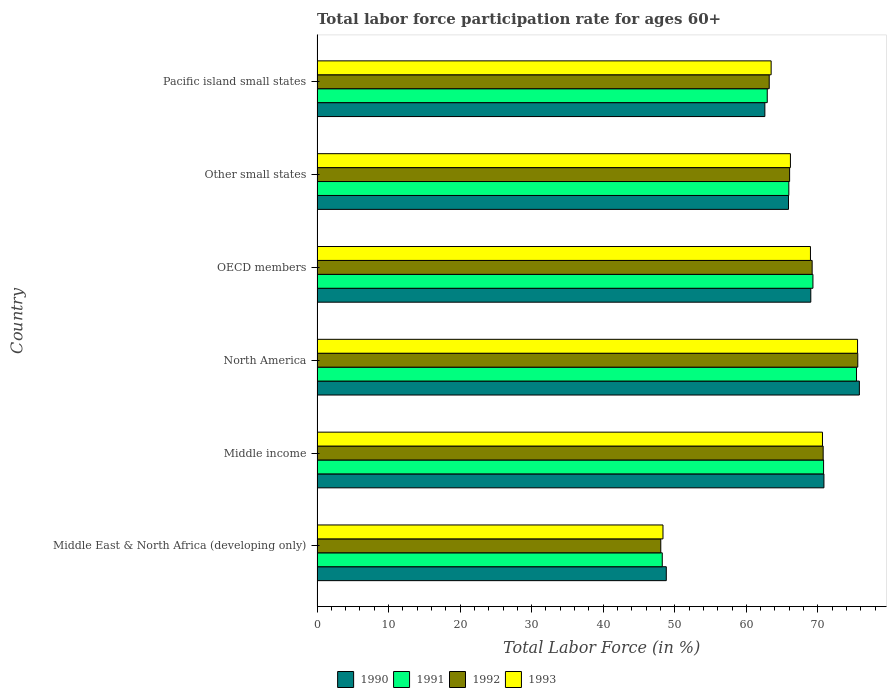How many groups of bars are there?
Give a very brief answer. 6. Are the number of bars per tick equal to the number of legend labels?
Your response must be concise. Yes. How many bars are there on the 5th tick from the top?
Ensure brevity in your answer.  4. How many bars are there on the 3rd tick from the bottom?
Keep it short and to the point. 4. In how many cases, is the number of bars for a given country not equal to the number of legend labels?
Provide a short and direct response. 0. What is the labor force participation rate in 1991 in Other small states?
Your answer should be compact. 65.94. Across all countries, what is the maximum labor force participation rate in 1992?
Offer a very short reply. 75.58. Across all countries, what is the minimum labor force participation rate in 1992?
Your response must be concise. 48.04. In which country was the labor force participation rate in 1990 maximum?
Your response must be concise. North America. In which country was the labor force participation rate in 1990 minimum?
Provide a short and direct response. Middle East & North Africa (developing only). What is the total labor force participation rate in 1990 in the graph?
Provide a succinct answer. 392.97. What is the difference between the labor force participation rate in 1993 in Other small states and that in Pacific island small states?
Offer a terse response. 2.69. What is the difference between the labor force participation rate in 1991 in Other small states and the labor force participation rate in 1993 in Middle income?
Your answer should be compact. -4.7. What is the average labor force participation rate in 1993 per country?
Provide a short and direct response. 65.52. What is the difference between the labor force participation rate in 1990 and labor force participation rate in 1991 in North America?
Offer a terse response. 0.4. In how many countries, is the labor force participation rate in 1992 greater than 76 %?
Your answer should be compact. 0. What is the ratio of the labor force participation rate in 1993 in Other small states to that in Pacific island small states?
Keep it short and to the point. 1.04. What is the difference between the highest and the second highest labor force participation rate in 1991?
Offer a very short reply. 4.6. What is the difference between the highest and the lowest labor force participation rate in 1990?
Give a very brief answer. 26.99. In how many countries, is the labor force participation rate in 1990 greater than the average labor force participation rate in 1990 taken over all countries?
Keep it short and to the point. 4. Is it the case that in every country, the sum of the labor force participation rate in 1991 and labor force participation rate in 1990 is greater than the sum of labor force participation rate in 1993 and labor force participation rate in 1992?
Give a very brief answer. No. What does the 1st bar from the top in OECD members represents?
Your answer should be compact. 1993. How many bars are there?
Give a very brief answer. 24. What is the difference between two consecutive major ticks on the X-axis?
Your answer should be very brief. 10. Are the values on the major ticks of X-axis written in scientific E-notation?
Provide a succinct answer. No. Does the graph contain any zero values?
Your answer should be very brief. No. How many legend labels are there?
Provide a short and direct response. 4. How are the legend labels stacked?
Your answer should be compact. Horizontal. What is the title of the graph?
Offer a terse response. Total labor force participation rate for ages 60+. What is the label or title of the X-axis?
Your response must be concise. Total Labor Force (in %). What is the Total Labor Force (in %) in 1990 in Middle East & North Africa (developing only)?
Your response must be concise. 48.82. What is the Total Labor Force (in %) of 1991 in Middle East & North Africa (developing only)?
Keep it short and to the point. 48.25. What is the Total Labor Force (in %) in 1992 in Middle East & North Africa (developing only)?
Keep it short and to the point. 48.04. What is the Total Labor Force (in %) in 1993 in Middle East & North Africa (developing only)?
Offer a terse response. 48.35. What is the Total Labor Force (in %) in 1990 in Middle income?
Provide a succinct answer. 70.85. What is the Total Labor Force (in %) in 1991 in Middle income?
Offer a very short reply. 70.8. What is the Total Labor Force (in %) of 1992 in Middle income?
Your answer should be very brief. 70.74. What is the Total Labor Force (in %) of 1993 in Middle income?
Ensure brevity in your answer.  70.64. What is the Total Labor Force (in %) of 1990 in North America?
Ensure brevity in your answer.  75.8. What is the Total Labor Force (in %) of 1991 in North America?
Provide a short and direct response. 75.4. What is the Total Labor Force (in %) in 1992 in North America?
Give a very brief answer. 75.58. What is the Total Labor Force (in %) of 1993 in North America?
Provide a succinct answer. 75.55. What is the Total Labor Force (in %) of 1990 in OECD members?
Keep it short and to the point. 69.01. What is the Total Labor Force (in %) of 1991 in OECD members?
Provide a short and direct response. 69.31. What is the Total Labor Force (in %) of 1992 in OECD members?
Keep it short and to the point. 69.2. What is the Total Labor Force (in %) in 1993 in OECD members?
Provide a succinct answer. 68.97. What is the Total Labor Force (in %) in 1990 in Other small states?
Ensure brevity in your answer.  65.9. What is the Total Labor Force (in %) in 1991 in Other small states?
Provide a succinct answer. 65.94. What is the Total Labor Force (in %) in 1992 in Other small states?
Provide a short and direct response. 66.05. What is the Total Labor Force (in %) in 1993 in Other small states?
Make the answer very short. 66.16. What is the Total Labor Force (in %) of 1990 in Pacific island small states?
Keep it short and to the point. 62.59. What is the Total Labor Force (in %) of 1991 in Pacific island small states?
Your answer should be very brief. 62.93. What is the Total Labor Force (in %) of 1992 in Pacific island small states?
Your answer should be compact. 63.2. What is the Total Labor Force (in %) of 1993 in Pacific island small states?
Make the answer very short. 63.47. Across all countries, what is the maximum Total Labor Force (in %) of 1990?
Offer a terse response. 75.8. Across all countries, what is the maximum Total Labor Force (in %) of 1991?
Offer a very short reply. 75.4. Across all countries, what is the maximum Total Labor Force (in %) in 1992?
Your response must be concise. 75.58. Across all countries, what is the maximum Total Labor Force (in %) in 1993?
Your response must be concise. 75.55. Across all countries, what is the minimum Total Labor Force (in %) of 1990?
Offer a very short reply. 48.82. Across all countries, what is the minimum Total Labor Force (in %) in 1991?
Give a very brief answer. 48.25. Across all countries, what is the minimum Total Labor Force (in %) in 1992?
Keep it short and to the point. 48.04. Across all countries, what is the minimum Total Labor Force (in %) in 1993?
Your answer should be compact. 48.35. What is the total Total Labor Force (in %) in 1990 in the graph?
Your answer should be very brief. 392.97. What is the total Total Labor Force (in %) of 1991 in the graph?
Provide a short and direct response. 392.64. What is the total Total Labor Force (in %) of 1992 in the graph?
Keep it short and to the point. 392.82. What is the total Total Labor Force (in %) in 1993 in the graph?
Provide a short and direct response. 393.15. What is the difference between the Total Labor Force (in %) in 1990 in Middle East & North Africa (developing only) and that in Middle income?
Ensure brevity in your answer.  -22.03. What is the difference between the Total Labor Force (in %) in 1991 in Middle East & North Africa (developing only) and that in Middle income?
Your response must be concise. -22.55. What is the difference between the Total Labor Force (in %) in 1992 in Middle East & North Africa (developing only) and that in Middle income?
Your answer should be very brief. -22.7. What is the difference between the Total Labor Force (in %) of 1993 in Middle East & North Africa (developing only) and that in Middle income?
Offer a very short reply. -22.29. What is the difference between the Total Labor Force (in %) of 1990 in Middle East & North Africa (developing only) and that in North America?
Your response must be concise. -26.99. What is the difference between the Total Labor Force (in %) in 1991 in Middle East & North Africa (developing only) and that in North America?
Provide a succinct answer. -27.15. What is the difference between the Total Labor Force (in %) of 1992 in Middle East & North Africa (developing only) and that in North America?
Offer a terse response. -27.53. What is the difference between the Total Labor Force (in %) of 1993 in Middle East & North Africa (developing only) and that in North America?
Make the answer very short. -27.2. What is the difference between the Total Labor Force (in %) in 1990 in Middle East & North Africa (developing only) and that in OECD members?
Keep it short and to the point. -20.2. What is the difference between the Total Labor Force (in %) of 1991 in Middle East & North Africa (developing only) and that in OECD members?
Your answer should be very brief. -21.06. What is the difference between the Total Labor Force (in %) of 1992 in Middle East & North Africa (developing only) and that in OECD members?
Your answer should be very brief. -21.16. What is the difference between the Total Labor Force (in %) of 1993 in Middle East & North Africa (developing only) and that in OECD members?
Ensure brevity in your answer.  -20.61. What is the difference between the Total Labor Force (in %) in 1990 in Middle East & North Africa (developing only) and that in Other small states?
Your answer should be very brief. -17.08. What is the difference between the Total Labor Force (in %) in 1991 in Middle East & North Africa (developing only) and that in Other small states?
Offer a very short reply. -17.69. What is the difference between the Total Labor Force (in %) in 1992 in Middle East & North Africa (developing only) and that in Other small states?
Keep it short and to the point. -18.01. What is the difference between the Total Labor Force (in %) in 1993 in Middle East & North Africa (developing only) and that in Other small states?
Offer a terse response. -17.81. What is the difference between the Total Labor Force (in %) in 1990 in Middle East & North Africa (developing only) and that in Pacific island small states?
Your answer should be compact. -13.78. What is the difference between the Total Labor Force (in %) of 1991 in Middle East & North Africa (developing only) and that in Pacific island small states?
Offer a terse response. -14.67. What is the difference between the Total Labor Force (in %) in 1992 in Middle East & North Africa (developing only) and that in Pacific island small states?
Provide a succinct answer. -15.16. What is the difference between the Total Labor Force (in %) of 1993 in Middle East & North Africa (developing only) and that in Pacific island small states?
Make the answer very short. -15.12. What is the difference between the Total Labor Force (in %) of 1990 in Middle income and that in North America?
Your answer should be very brief. -4.95. What is the difference between the Total Labor Force (in %) of 1991 in Middle income and that in North America?
Give a very brief answer. -4.6. What is the difference between the Total Labor Force (in %) of 1992 in Middle income and that in North America?
Offer a very short reply. -4.84. What is the difference between the Total Labor Force (in %) in 1993 in Middle income and that in North America?
Offer a very short reply. -4.9. What is the difference between the Total Labor Force (in %) in 1990 in Middle income and that in OECD members?
Your response must be concise. 1.84. What is the difference between the Total Labor Force (in %) in 1991 in Middle income and that in OECD members?
Your answer should be very brief. 1.49. What is the difference between the Total Labor Force (in %) of 1992 in Middle income and that in OECD members?
Make the answer very short. 1.54. What is the difference between the Total Labor Force (in %) of 1993 in Middle income and that in OECD members?
Provide a short and direct response. 1.68. What is the difference between the Total Labor Force (in %) in 1990 in Middle income and that in Other small states?
Your response must be concise. 4.95. What is the difference between the Total Labor Force (in %) in 1991 in Middle income and that in Other small states?
Your answer should be very brief. 4.86. What is the difference between the Total Labor Force (in %) of 1992 in Middle income and that in Other small states?
Offer a terse response. 4.69. What is the difference between the Total Labor Force (in %) of 1993 in Middle income and that in Other small states?
Provide a succinct answer. 4.48. What is the difference between the Total Labor Force (in %) in 1990 in Middle income and that in Pacific island small states?
Keep it short and to the point. 8.26. What is the difference between the Total Labor Force (in %) of 1991 in Middle income and that in Pacific island small states?
Give a very brief answer. 7.87. What is the difference between the Total Labor Force (in %) in 1992 in Middle income and that in Pacific island small states?
Give a very brief answer. 7.54. What is the difference between the Total Labor Force (in %) of 1993 in Middle income and that in Pacific island small states?
Offer a very short reply. 7.17. What is the difference between the Total Labor Force (in %) of 1990 in North America and that in OECD members?
Keep it short and to the point. 6.79. What is the difference between the Total Labor Force (in %) in 1991 in North America and that in OECD members?
Provide a succinct answer. 6.09. What is the difference between the Total Labor Force (in %) in 1992 in North America and that in OECD members?
Offer a terse response. 6.38. What is the difference between the Total Labor Force (in %) of 1993 in North America and that in OECD members?
Ensure brevity in your answer.  6.58. What is the difference between the Total Labor Force (in %) in 1990 in North America and that in Other small states?
Give a very brief answer. 9.91. What is the difference between the Total Labor Force (in %) in 1991 in North America and that in Other small states?
Your answer should be very brief. 9.46. What is the difference between the Total Labor Force (in %) of 1992 in North America and that in Other small states?
Keep it short and to the point. 9.53. What is the difference between the Total Labor Force (in %) of 1993 in North America and that in Other small states?
Offer a terse response. 9.38. What is the difference between the Total Labor Force (in %) of 1990 in North America and that in Pacific island small states?
Provide a succinct answer. 13.21. What is the difference between the Total Labor Force (in %) of 1991 in North America and that in Pacific island small states?
Make the answer very short. 12.48. What is the difference between the Total Labor Force (in %) in 1992 in North America and that in Pacific island small states?
Your answer should be compact. 12.38. What is the difference between the Total Labor Force (in %) of 1993 in North America and that in Pacific island small states?
Provide a succinct answer. 12.08. What is the difference between the Total Labor Force (in %) of 1990 in OECD members and that in Other small states?
Make the answer very short. 3.12. What is the difference between the Total Labor Force (in %) in 1991 in OECD members and that in Other small states?
Your answer should be compact. 3.37. What is the difference between the Total Labor Force (in %) of 1992 in OECD members and that in Other small states?
Provide a short and direct response. 3.15. What is the difference between the Total Labor Force (in %) of 1993 in OECD members and that in Other small states?
Offer a terse response. 2.8. What is the difference between the Total Labor Force (in %) of 1990 in OECD members and that in Pacific island small states?
Ensure brevity in your answer.  6.42. What is the difference between the Total Labor Force (in %) of 1991 in OECD members and that in Pacific island small states?
Ensure brevity in your answer.  6.39. What is the difference between the Total Labor Force (in %) of 1992 in OECD members and that in Pacific island small states?
Offer a very short reply. 6. What is the difference between the Total Labor Force (in %) in 1993 in OECD members and that in Pacific island small states?
Your response must be concise. 5.49. What is the difference between the Total Labor Force (in %) in 1990 in Other small states and that in Pacific island small states?
Ensure brevity in your answer.  3.3. What is the difference between the Total Labor Force (in %) in 1991 in Other small states and that in Pacific island small states?
Make the answer very short. 3.02. What is the difference between the Total Labor Force (in %) in 1992 in Other small states and that in Pacific island small states?
Make the answer very short. 2.85. What is the difference between the Total Labor Force (in %) in 1993 in Other small states and that in Pacific island small states?
Your response must be concise. 2.69. What is the difference between the Total Labor Force (in %) of 1990 in Middle East & North Africa (developing only) and the Total Labor Force (in %) of 1991 in Middle income?
Provide a succinct answer. -21.98. What is the difference between the Total Labor Force (in %) of 1990 in Middle East & North Africa (developing only) and the Total Labor Force (in %) of 1992 in Middle income?
Provide a succinct answer. -21.93. What is the difference between the Total Labor Force (in %) in 1990 in Middle East & North Africa (developing only) and the Total Labor Force (in %) in 1993 in Middle income?
Provide a succinct answer. -21.83. What is the difference between the Total Labor Force (in %) of 1991 in Middle East & North Africa (developing only) and the Total Labor Force (in %) of 1992 in Middle income?
Your answer should be compact. -22.49. What is the difference between the Total Labor Force (in %) of 1991 in Middle East & North Africa (developing only) and the Total Labor Force (in %) of 1993 in Middle income?
Provide a short and direct response. -22.39. What is the difference between the Total Labor Force (in %) in 1992 in Middle East & North Africa (developing only) and the Total Labor Force (in %) in 1993 in Middle income?
Offer a terse response. -22.6. What is the difference between the Total Labor Force (in %) in 1990 in Middle East & North Africa (developing only) and the Total Labor Force (in %) in 1991 in North America?
Ensure brevity in your answer.  -26.59. What is the difference between the Total Labor Force (in %) in 1990 in Middle East & North Africa (developing only) and the Total Labor Force (in %) in 1992 in North America?
Ensure brevity in your answer.  -26.76. What is the difference between the Total Labor Force (in %) of 1990 in Middle East & North Africa (developing only) and the Total Labor Force (in %) of 1993 in North America?
Provide a short and direct response. -26.73. What is the difference between the Total Labor Force (in %) in 1991 in Middle East & North Africa (developing only) and the Total Labor Force (in %) in 1992 in North America?
Provide a succinct answer. -27.33. What is the difference between the Total Labor Force (in %) of 1991 in Middle East & North Africa (developing only) and the Total Labor Force (in %) of 1993 in North America?
Your response must be concise. -27.3. What is the difference between the Total Labor Force (in %) in 1992 in Middle East & North Africa (developing only) and the Total Labor Force (in %) in 1993 in North America?
Offer a terse response. -27.5. What is the difference between the Total Labor Force (in %) of 1990 in Middle East & North Africa (developing only) and the Total Labor Force (in %) of 1991 in OECD members?
Offer a very short reply. -20.5. What is the difference between the Total Labor Force (in %) in 1990 in Middle East & North Africa (developing only) and the Total Labor Force (in %) in 1992 in OECD members?
Your answer should be very brief. -20.39. What is the difference between the Total Labor Force (in %) in 1990 in Middle East & North Africa (developing only) and the Total Labor Force (in %) in 1993 in OECD members?
Your answer should be compact. -20.15. What is the difference between the Total Labor Force (in %) of 1991 in Middle East & North Africa (developing only) and the Total Labor Force (in %) of 1992 in OECD members?
Your answer should be compact. -20.95. What is the difference between the Total Labor Force (in %) in 1991 in Middle East & North Africa (developing only) and the Total Labor Force (in %) in 1993 in OECD members?
Provide a short and direct response. -20.71. What is the difference between the Total Labor Force (in %) in 1992 in Middle East & North Africa (developing only) and the Total Labor Force (in %) in 1993 in OECD members?
Provide a short and direct response. -20.92. What is the difference between the Total Labor Force (in %) in 1990 in Middle East & North Africa (developing only) and the Total Labor Force (in %) in 1991 in Other small states?
Your answer should be very brief. -17.13. What is the difference between the Total Labor Force (in %) in 1990 in Middle East & North Africa (developing only) and the Total Labor Force (in %) in 1992 in Other small states?
Your answer should be very brief. -17.24. What is the difference between the Total Labor Force (in %) in 1990 in Middle East & North Africa (developing only) and the Total Labor Force (in %) in 1993 in Other small states?
Offer a very short reply. -17.35. What is the difference between the Total Labor Force (in %) of 1991 in Middle East & North Africa (developing only) and the Total Labor Force (in %) of 1992 in Other small states?
Provide a succinct answer. -17.8. What is the difference between the Total Labor Force (in %) of 1991 in Middle East & North Africa (developing only) and the Total Labor Force (in %) of 1993 in Other small states?
Provide a succinct answer. -17.91. What is the difference between the Total Labor Force (in %) in 1992 in Middle East & North Africa (developing only) and the Total Labor Force (in %) in 1993 in Other small states?
Your response must be concise. -18.12. What is the difference between the Total Labor Force (in %) in 1990 in Middle East & North Africa (developing only) and the Total Labor Force (in %) in 1991 in Pacific island small states?
Offer a very short reply. -14.11. What is the difference between the Total Labor Force (in %) of 1990 in Middle East & North Africa (developing only) and the Total Labor Force (in %) of 1992 in Pacific island small states?
Offer a terse response. -14.38. What is the difference between the Total Labor Force (in %) of 1990 in Middle East & North Africa (developing only) and the Total Labor Force (in %) of 1993 in Pacific island small states?
Provide a short and direct response. -14.65. What is the difference between the Total Labor Force (in %) in 1991 in Middle East & North Africa (developing only) and the Total Labor Force (in %) in 1992 in Pacific island small states?
Offer a very short reply. -14.95. What is the difference between the Total Labor Force (in %) of 1991 in Middle East & North Africa (developing only) and the Total Labor Force (in %) of 1993 in Pacific island small states?
Offer a terse response. -15.22. What is the difference between the Total Labor Force (in %) of 1992 in Middle East & North Africa (developing only) and the Total Labor Force (in %) of 1993 in Pacific island small states?
Make the answer very short. -15.43. What is the difference between the Total Labor Force (in %) in 1990 in Middle income and the Total Labor Force (in %) in 1991 in North America?
Offer a terse response. -4.55. What is the difference between the Total Labor Force (in %) of 1990 in Middle income and the Total Labor Force (in %) of 1992 in North America?
Offer a very short reply. -4.73. What is the difference between the Total Labor Force (in %) in 1990 in Middle income and the Total Labor Force (in %) in 1993 in North America?
Make the answer very short. -4.7. What is the difference between the Total Labor Force (in %) of 1991 in Middle income and the Total Labor Force (in %) of 1992 in North America?
Make the answer very short. -4.78. What is the difference between the Total Labor Force (in %) of 1991 in Middle income and the Total Labor Force (in %) of 1993 in North America?
Ensure brevity in your answer.  -4.75. What is the difference between the Total Labor Force (in %) of 1992 in Middle income and the Total Labor Force (in %) of 1993 in North America?
Your answer should be compact. -4.81. What is the difference between the Total Labor Force (in %) of 1990 in Middle income and the Total Labor Force (in %) of 1991 in OECD members?
Your answer should be very brief. 1.54. What is the difference between the Total Labor Force (in %) in 1990 in Middle income and the Total Labor Force (in %) in 1992 in OECD members?
Your response must be concise. 1.65. What is the difference between the Total Labor Force (in %) of 1990 in Middle income and the Total Labor Force (in %) of 1993 in OECD members?
Provide a succinct answer. 1.89. What is the difference between the Total Labor Force (in %) in 1991 in Middle income and the Total Labor Force (in %) in 1992 in OECD members?
Provide a succinct answer. 1.6. What is the difference between the Total Labor Force (in %) of 1991 in Middle income and the Total Labor Force (in %) of 1993 in OECD members?
Provide a short and direct response. 1.84. What is the difference between the Total Labor Force (in %) in 1992 in Middle income and the Total Labor Force (in %) in 1993 in OECD members?
Offer a terse response. 1.78. What is the difference between the Total Labor Force (in %) of 1990 in Middle income and the Total Labor Force (in %) of 1991 in Other small states?
Your answer should be very brief. 4.91. What is the difference between the Total Labor Force (in %) in 1990 in Middle income and the Total Labor Force (in %) in 1992 in Other small states?
Ensure brevity in your answer.  4.8. What is the difference between the Total Labor Force (in %) in 1990 in Middle income and the Total Labor Force (in %) in 1993 in Other small states?
Your answer should be very brief. 4.69. What is the difference between the Total Labor Force (in %) in 1991 in Middle income and the Total Labor Force (in %) in 1992 in Other small states?
Make the answer very short. 4.75. What is the difference between the Total Labor Force (in %) of 1991 in Middle income and the Total Labor Force (in %) of 1993 in Other small states?
Your answer should be very brief. 4.64. What is the difference between the Total Labor Force (in %) of 1992 in Middle income and the Total Labor Force (in %) of 1993 in Other small states?
Your answer should be very brief. 4.58. What is the difference between the Total Labor Force (in %) in 1990 in Middle income and the Total Labor Force (in %) in 1991 in Pacific island small states?
Give a very brief answer. 7.92. What is the difference between the Total Labor Force (in %) of 1990 in Middle income and the Total Labor Force (in %) of 1992 in Pacific island small states?
Provide a short and direct response. 7.65. What is the difference between the Total Labor Force (in %) of 1990 in Middle income and the Total Labor Force (in %) of 1993 in Pacific island small states?
Make the answer very short. 7.38. What is the difference between the Total Labor Force (in %) in 1991 in Middle income and the Total Labor Force (in %) in 1992 in Pacific island small states?
Offer a terse response. 7.6. What is the difference between the Total Labor Force (in %) of 1991 in Middle income and the Total Labor Force (in %) of 1993 in Pacific island small states?
Provide a succinct answer. 7.33. What is the difference between the Total Labor Force (in %) of 1992 in Middle income and the Total Labor Force (in %) of 1993 in Pacific island small states?
Ensure brevity in your answer.  7.27. What is the difference between the Total Labor Force (in %) of 1990 in North America and the Total Labor Force (in %) of 1991 in OECD members?
Ensure brevity in your answer.  6.49. What is the difference between the Total Labor Force (in %) in 1990 in North America and the Total Labor Force (in %) in 1992 in OECD members?
Provide a short and direct response. 6.6. What is the difference between the Total Labor Force (in %) of 1990 in North America and the Total Labor Force (in %) of 1993 in OECD members?
Make the answer very short. 6.84. What is the difference between the Total Labor Force (in %) of 1991 in North America and the Total Labor Force (in %) of 1992 in OECD members?
Provide a short and direct response. 6.2. What is the difference between the Total Labor Force (in %) in 1991 in North America and the Total Labor Force (in %) in 1993 in OECD members?
Give a very brief answer. 6.44. What is the difference between the Total Labor Force (in %) of 1992 in North America and the Total Labor Force (in %) of 1993 in OECD members?
Ensure brevity in your answer.  6.61. What is the difference between the Total Labor Force (in %) of 1990 in North America and the Total Labor Force (in %) of 1991 in Other small states?
Your answer should be compact. 9.86. What is the difference between the Total Labor Force (in %) of 1990 in North America and the Total Labor Force (in %) of 1992 in Other small states?
Your response must be concise. 9.75. What is the difference between the Total Labor Force (in %) in 1990 in North America and the Total Labor Force (in %) in 1993 in Other small states?
Your response must be concise. 9.64. What is the difference between the Total Labor Force (in %) of 1991 in North America and the Total Labor Force (in %) of 1992 in Other small states?
Your answer should be very brief. 9.35. What is the difference between the Total Labor Force (in %) of 1991 in North America and the Total Labor Force (in %) of 1993 in Other small states?
Ensure brevity in your answer.  9.24. What is the difference between the Total Labor Force (in %) in 1992 in North America and the Total Labor Force (in %) in 1993 in Other small states?
Offer a terse response. 9.41. What is the difference between the Total Labor Force (in %) of 1990 in North America and the Total Labor Force (in %) of 1991 in Pacific island small states?
Provide a short and direct response. 12.88. What is the difference between the Total Labor Force (in %) in 1990 in North America and the Total Labor Force (in %) in 1992 in Pacific island small states?
Provide a short and direct response. 12.6. What is the difference between the Total Labor Force (in %) in 1990 in North America and the Total Labor Force (in %) in 1993 in Pacific island small states?
Keep it short and to the point. 12.33. What is the difference between the Total Labor Force (in %) in 1991 in North America and the Total Labor Force (in %) in 1992 in Pacific island small states?
Provide a succinct answer. 12.2. What is the difference between the Total Labor Force (in %) of 1991 in North America and the Total Labor Force (in %) of 1993 in Pacific island small states?
Provide a short and direct response. 11.93. What is the difference between the Total Labor Force (in %) of 1992 in North America and the Total Labor Force (in %) of 1993 in Pacific island small states?
Make the answer very short. 12.11. What is the difference between the Total Labor Force (in %) of 1990 in OECD members and the Total Labor Force (in %) of 1991 in Other small states?
Make the answer very short. 3.07. What is the difference between the Total Labor Force (in %) of 1990 in OECD members and the Total Labor Force (in %) of 1992 in Other small states?
Offer a terse response. 2.96. What is the difference between the Total Labor Force (in %) of 1990 in OECD members and the Total Labor Force (in %) of 1993 in Other small states?
Give a very brief answer. 2.85. What is the difference between the Total Labor Force (in %) in 1991 in OECD members and the Total Labor Force (in %) in 1992 in Other small states?
Keep it short and to the point. 3.26. What is the difference between the Total Labor Force (in %) of 1991 in OECD members and the Total Labor Force (in %) of 1993 in Other small states?
Offer a very short reply. 3.15. What is the difference between the Total Labor Force (in %) of 1992 in OECD members and the Total Labor Force (in %) of 1993 in Other small states?
Your answer should be very brief. 3.04. What is the difference between the Total Labor Force (in %) of 1990 in OECD members and the Total Labor Force (in %) of 1991 in Pacific island small states?
Your response must be concise. 6.09. What is the difference between the Total Labor Force (in %) in 1990 in OECD members and the Total Labor Force (in %) in 1992 in Pacific island small states?
Provide a short and direct response. 5.81. What is the difference between the Total Labor Force (in %) in 1990 in OECD members and the Total Labor Force (in %) in 1993 in Pacific island small states?
Give a very brief answer. 5.54. What is the difference between the Total Labor Force (in %) of 1991 in OECD members and the Total Labor Force (in %) of 1992 in Pacific island small states?
Give a very brief answer. 6.11. What is the difference between the Total Labor Force (in %) in 1991 in OECD members and the Total Labor Force (in %) in 1993 in Pacific island small states?
Offer a very short reply. 5.84. What is the difference between the Total Labor Force (in %) of 1992 in OECD members and the Total Labor Force (in %) of 1993 in Pacific island small states?
Keep it short and to the point. 5.73. What is the difference between the Total Labor Force (in %) in 1990 in Other small states and the Total Labor Force (in %) in 1991 in Pacific island small states?
Give a very brief answer. 2.97. What is the difference between the Total Labor Force (in %) in 1990 in Other small states and the Total Labor Force (in %) in 1992 in Pacific island small states?
Make the answer very short. 2.7. What is the difference between the Total Labor Force (in %) of 1990 in Other small states and the Total Labor Force (in %) of 1993 in Pacific island small states?
Ensure brevity in your answer.  2.43. What is the difference between the Total Labor Force (in %) of 1991 in Other small states and the Total Labor Force (in %) of 1992 in Pacific island small states?
Keep it short and to the point. 2.74. What is the difference between the Total Labor Force (in %) in 1991 in Other small states and the Total Labor Force (in %) in 1993 in Pacific island small states?
Provide a short and direct response. 2.47. What is the difference between the Total Labor Force (in %) of 1992 in Other small states and the Total Labor Force (in %) of 1993 in Pacific island small states?
Ensure brevity in your answer.  2.58. What is the average Total Labor Force (in %) in 1990 per country?
Your response must be concise. 65.5. What is the average Total Labor Force (in %) of 1991 per country?
Your response must be concise. 65.44. What is the average Total Labor Force (in %) of 1992 per country?
Keep it short and to the point. 65.47. What is the average Total Labor Force (in %) in 1993 per country?
Your response must be concise. 65.52. What is the difference between the Total Labor Force (in %) in 1990 and Total Labor Force (in %) in 1991 in Middle East & North Africa (developing only)?
Your response must be concise. 0.56. What is the difference between the Total Labor Force (in %) of 1990 and Total Labor Force (in %) of 1992 in Middle East & North Africa (developing only)?
Keep it short and to the point. 0.77. What is the difference between the Total Labor Force (in %) in 1990 and Total Labor Force (in %) in 1993 in Middle East & North Africa (developing only)?
Give a very brief answer. 0.46. What is the difference between the Total Labor Force (in %) in 1991 and Total Labor Force (in %) in 1992 in Middle East & North Africa (developing only)?
Your response must be concise. 0.21. What is the difference between the Total Labor Force (in %) in 1991 and Total Labor Force (in %) in 1993 in Middle East & North Africa (developing only)?
Your answer should be compact. -0.1. What is the difference between the Total Labor Force (in %) of 1992 and Total Labor Force (in %) of 1993 in Middle East & North Africa (developing only)?
Offer a very short reply. -0.31. What is the difference between the Total Labor Force (in %) of 1990 and Total Labor Force (in %) of 1991 in Middle income?
Keep it short and to the point. 0.05. What is the difference between the Total Labor Force (in %) of 1990 and Total Labor Force (in %) of 1992 in Middle income?
Keep it short and to the point. 0.11. What is the difference between the Total Labor Force (in %) in 1990 and Total Labor Force (in %) in 1993 in Middle income?
Give a very brief answer. 0.21. What is the difference between the Total Labor Force (in %) of 1991 and Total Labor Force (in %) of 1992 in Middle income?
Give a very brief answer. 0.06. What is the difference between the Total Labor Force (in %) of 1991 and Total Labor Force (in %) of 1993 in Middle income?
Offer a terse response. 0.16. What is the difference between the Total Labor Force (in %) in 1992 and Total Labor Force (in %) in 1993 in Middle income?
Keep it short and to the point. 0.1. What is the difference between the Total Labor Force (in %) in 1990 and Total Labor Force (in %) in 1991 in North America?
Ensure brevity in your answer.  0.4. What is the difference between the Total Labor Force (in %) of 1990 and Total Labor Force (in %) of 1992 in North America?
Keep it short and to the point. 0.22. What is the difference between the Total Labor Force (in %) in 1990 and Total Labor Force (in %) in 1993 in North America?
Offer a terse response. 0.25. What is the difference between the Total Labor Force (in %) of 1991 and Total Labor Force (in %) of 1992 in North America?
Ensure brevity in your answer.  -0.18. What is the difference between the Total Labor Force (in %) in 1991 and Total Labor Force (in %) in 1993 in North America?
Your answer should be very brief. -0.15. What is the difference between the Total Labor Force (in %) in 1992 and Total Labor Force (in %) in 1993 in North America?
Offer a very short reply. 0.03. What is the difference between the Total Labor Force (in %) of 1990 and Total Labor Force (in %) of 1991 in OECD members?
Keep it short and to the point. -0.3. What is the difference between the Total Labor Force (in %) in 1990 and Total Labor Force (in %) in 1992 in OECD members?
Keep it short and to the point. -0.19. What is the difference between the Total Labor Force (in %) in 1990 and Total Labor Force (in %) in 1993 in OECD members?
Ensure brevity in your answer.  0.05. What is the difference between the Total Labor Force (in %) of 1991 and Total Labor Force (in %) of 1992 in OECD members?
Provide a succinct answer. 0.11. What is the difference between the Total Labor Force (in %) of 1991 and Total Labor Force (in %) of 1993 in OECD members?
Offer a very short reply. 0.35. What is the difference between the Total Labor Force (in %) of 1992 and Total Labor Force (in %) of 1993 in OECD members?
Make the answer very short. 0.24. What is the difference between the Total Labor Force (in %) in 1990 and Total Labor Force (in %) in 1991 in Other small states?
Your response must be concise. -0.05. What is the difference between the Total Labor Force (in %) of 1990 and Total Labor Force (in %) of 1992 in Other small states?
Keep it short and to the point. -0.16. What is the difference between the Total Labor Force (in %) of 1990 and Total Labor Force (in %) of 1993 in Other small states?
Keep it short and to the point. -0.27. What is the difference between the Total Labor Force (in %) of 1991 and Total Labor Force (in %) of 1992 in Other small states?
Give a very brief answer. -0.11. What is the difference between the Total Labor Force (in %) in 1991 and Total Labor Force (in %) in 1993 in Other small states?
Provide a succinct answer. -0.22. What is the difference between the Total Labor Force (in %) in 1992 and Total Labor Force (in %) in 1993 in Other small states?
Your answer should be very brief. -0.11. What is the difference between the Total Labor Force (in %) of 1990 and Total Labor Force (in %) of 1991 in Pacific island small states?
Provide a short and direct response. -0.33. What is the difference between the Total Labor Force (in %) of 1990 and Total Labor Force (in %) of 1992 in Pacific island small states?
Give a very brief answer. -0.61. What is the difference between the Total Labor Force (in %) in 1990 and Total Labor Force (in %) in 1993 in Pacific island small states?
Your answer should be compact. -0.88. What is the difference between the Total Labor Force (in %) of 1991 and Total Labor Force (in %) of 1992 in Pacific island small states?
Ensure brevity in your answer.  -0.27. What is the difference between the Total Labor Force (in %) of 1991 and Total Labor Force (in %) of 1993 in Pacific island small states?
Your answer should be compact. -0.54. What is the difference between the Total Labor Force (in %) in 1992 and Total Labor Force (in %) in 1993 in Pacific island small states?
Your response must be concise. -0.27. What is the ratio of the Total Labor Force (in %) of 1990 in Middle East & North Africa (developing only) to that in Middle income?
Your answer should be compact. 0.69. What is the ratio of the Total Labor Force (in %) of 1991 in Middle East & North Africa (developing only) to that in Middle income?
Provide a succinct answer. 0.68. What is the ratio of the Total Labor Force (in %) of 1992 in Middle East & North Africa (developing only) to that in Middle income?
Ensure brevity in your answer.  0.68. What is the ratio of the Total Labor Force (in %) in 1993 in Middle East & North Africa (developing only) to that in Middle income?
Your answer should be very brief. 0.68. What is the ratio of the Total Labor Force (in %) in 1990 in Middle East & North Africa (developing only) to that in North America?
Make the answer very short. 0.64. What is the ratio of the Total Labor Force (in %) in 1991 in Middle East & North Africa (developing only) to that in North America?
Make the answer very short. 0.64. What is the ratio of the Total Labor Force (in %) of 1992 in Middle East & North Africa (developing only) to that in North America?
Offer a terse response. 0.64. What is the ratio of the Total Labor Force (in %) in 1993 in Middle East & North Africa (developing only) to that in North America?
Offer a very short reply. 0.64. What is the ratio of the Total Labor Force (in %) of 1990 in Middle East & North Africa (developing only) to that in OECD members?
Ensure brevity in your answer.  0.71. What is the ratio of the Total Labor Force (in %) in 1991 in Middle East & North Africa (developing only) to that in OECD members?
Offer a terse response. 0.7. What is the ratio of the Total Labor Force (in %) of 1992 in Middle East & North Africa (developing only) to that in OECD members?
Your answer should be very brief. 0.69. What is the ratio of the Total Labor Force (in %) of 1993 in Middle East & North Africa (developing only) to that in OECD members?
Give a very brief answer. 0.7. What is the ratio of the Total Labor Force (in %) of 1990 in Middle East & North Africa (developing only) to that in Other small states?
Ensure brevity in your answer.  0.74. What is the ratio of the Total Labor Force (in %) in 1991 in Middle East & North Africa (developing only) to that in Other small states?
Your answer should be compact. 0.73. What is the ratio of the Total Labor Force (in %) of 1992 in Middle East & North Africa (developing only) to that in Other small states?
Give a very brief answer. 0.73. What is the ratio of the Total Labor Force (in %) of 1993 in Middle East & North Africa (developing only) to that in Other small states?
Give a very brief answer. 0.73. What is the ratio of the Total Labor Force (in %) in 1990 in Middle East & North Africa (developing only) to that in Pacific island small states?
Your answer should be compact. 0.78. What is the ratio of the Total Labor Force (in %) of 1991 in Middle East & North Africa (developing only) to that in Pacific island small states?
Your answer should be compact. 0.77. What is the ratio of the Total Labor Force (in %) of 1992 in Middle East & North Africa (developing only) to that in Pacific island small states?
Give a very brief answer. 0.76. What is the ratio of the Total Labor Force (in %) of 1993 in Middle East & North Africa (developing only) to that in Pacific island small states?
Your answer should be very brief. 0.76. What is the ratio of the Total Labor Force (in %) in 1990 in Middle income to that in North America?
Offer a very short reply. 0.93. What is the ratio of the Total Labor Force (in %) in 1991 in Middle income to that in North America?
Provide a short and direct response. 0.94. What is the ratio of the Total Labor Force (in %) of 1992 in Middle income to that in North America?
Ensure brevity in your answer.  0.94. What is the ratio of the Total Labor Force (in %) in 1993 in Middle income to that in North America?
Keep it short and to the point. 0.94. What is the ratio of the Total Labor Force (in %) of 1990 in Middle income to that in OECD members?
Keep it short and to the point. 1.03. What is the ratio of the Total Labor Force (in %) of 1991 in Middle income to that in OECD members?
Provide a short and direct response. 1.02. What is the ratio of the Total Labor Force (in %) in 1992 in Middle income to that in OECD members?
Offer a terse response. 1.02. What is the ratio of the Total Labor Force (in %) in 1993 in Middle income to that in OECD members?
Keep it short and to the point. 1.02. What is the ratio of the Total Labor Force (in %) in 1990 in Middle income to that in Other small states?
Provide a short and direct response. 1.08. What is the ratio of the Total Labor Force (in %) of 1991 in Middle income to that in Other small states?
Provide a succinct answer. 1.07. What is the ratio of the Total Labor Force (in %) of 1992 in Middle income to that in Other small states?
Offer a terse response. 1.07. What is the ratio of the Total Labor Force (in %) in 1993 in Middle income to that in Other small states?
Ensure brevity in your answer.  1.07. What is the ratio of the Total Labor Force (in %) of 1990 in Middle income to that in Pacific island small states?
Provide a short and direct response. 1.13. What is the ratio of the Total Labor Force (in %) in 1991 in Middle income to that in Pacific island small states?
Ensure brevity in your answer.  1.13. What is the ratio of the Total Labor Force (in %) in 1992 in Middle income to that in Pacific island small states?
Offer a very short reply. 1.12. What is the ratio of the Total Labor Force (in %) of 1993 in Middle income to that in Pacific island small states?
Provide a short and direct response. 1.11. What is the ratio of the Total Labor Force (in %) in 1990 in North America to that in OECD members?
Make the answer very short. 1.1. What is the ratio of the Total Labor Force (in %) in 1991 in North America to that in OECD members?
Keep it short and to the point. 1.09. What is the ratio of the Total Labor Force (in %) of 1992 in North America to that in OECD members?
Your response must be concise. 1.09. What is the ratio of the Total Labor Force (in %) of 1993 in North America to that in OECD members?
Your response must be concise. 1.1. What is the ratio of the Total Labor Force (in %) of 1990 in North America to that in Other small states?
Provide a short and direct response. 1.15. What is the ratio of the Total Labor Force (in %) in 1991 in North America to that in Other small states?
Offer a very short reply. 1.14. What is the ratio of the Total Labor Force (in %) of 1992 in North America to that in Other small states?
Your response must be concise. 1.14. What is the ratio of the Total Labor Force (in %) of 1993 in North America to that in Other small states?
Your answer should be compact. 1.14. What is the ratio of the Total Labor Force (in %) of 1990 in North America to that in Pacific island small states?
Keep it short and to the point. 1.21. What is the ratio of the Total Labor Force (in %) of 1991 in North America to that in Pacific island small states?
Provide a short and direct response. 1.2. What is the ratio of the Total Labor Force (in %) of 1992 in North America to that in Pacific island small states?
Keep it short and to the point. 1.2. What is the ratio of the Total Labor Force (in %) in 1993 in North America to that in Pacific island small states?
Your answer should be compact. 1.19. What is the ratio of the Total Labor Force (in %) in 1990 in OECD members to that in Other small states?
Offer a very short reply. 1.05. What is the ratio of the Total Labor Force (in %) in 1991 in OECD members to that in Other small states?
Your answer should be very brief. 1.05. What is the ratio of the Total Labor Force (in %) in 1992 in OECD members to that in Other small states?
Your answer should be very brief. 1.05. What is the ratio of the Total Labor Force (in %) of 1993 in OECD members to that in Other small states?
Keep it short and to the point. 1.04. What is the ratio of the Total Labor Force (in %) in 1990 in OECD members to that in Pacific island small states?
Your response must be concise. 1.1. What is the ratio of the Total Labor Force (in %) of 1991 in OECD members to that in Pacific island small states?
Your response must be concise. 1.1. What is the ratio of the Total Labor Force (in %) of 1992 in OECD members to that in Pacific island small states?
Offer a terse response. 1.09. What is the ratio of the Total Labor Force (in %) in 1993 in OECD members to that in Pacific island small states?
Ensure brevity in your answer.  1.09. What is the ratio of the Total Labor Force (in %) in 1990 in Other small states to that in Pacific island small states?
Your response must be concise. 1.05. What is the ratio of the Total Labor Force (in %) in 1991 in Other small states to that in Pacific island small states?
Provide a succinct answer. 1.05. What is the ratio of the Total Labor Force (in %) in 1992 in Other small states to that in Pacific island small states?
Offer a terse response. 1.05. What is the ratio of the Total Labor Force (in %) of 1993 in Other small states to that in Pacific island small states?
Ensure brevity in your answer.  1.04. What is the difference between the highest and the second highest Total Labor Force (in %) in 1990?
Give a very brief answer. 4.95. What is the difference between the highest and the second highest Total Labor Force (in %) in 1991?
Offer a very short reply. 4.6. What is the difference between the highest and the second highest Total Labor Force (in %) in 1992?
Provide a succinct answer. 4.84. What is the difference between the highest and the second highest Total Labor Force (in %) of 1993?
Your response must be concise. 4.9. What is the difference between the highest and the lowest Total Labor Force (in %) in 1990?
Your answer should be very brief. 26.99. What is the difference between the highest and the lowest Total Labor Force (in %) of 1991?
Your response must be concise. 27.15. What is the difference between the highest and the lowest Total Labor Force (in %) of 1992?
Give a very brief answer. 27.53. What is the difference between the highest and the lowest Total Labor Force (in %) of 1993?
Make the answer very short. 27.2. 